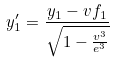Convert formula to latex. <formula><loc_0><loc_0><loc_500><loc_500>y _ { 1 } ^ { \prime } = \frac { y _ { 1 } - v f _ { 1 } } { \sqrt { 1 - \frac { v ^ { 3 } } { e ^ { 3 } } } }</formula> 